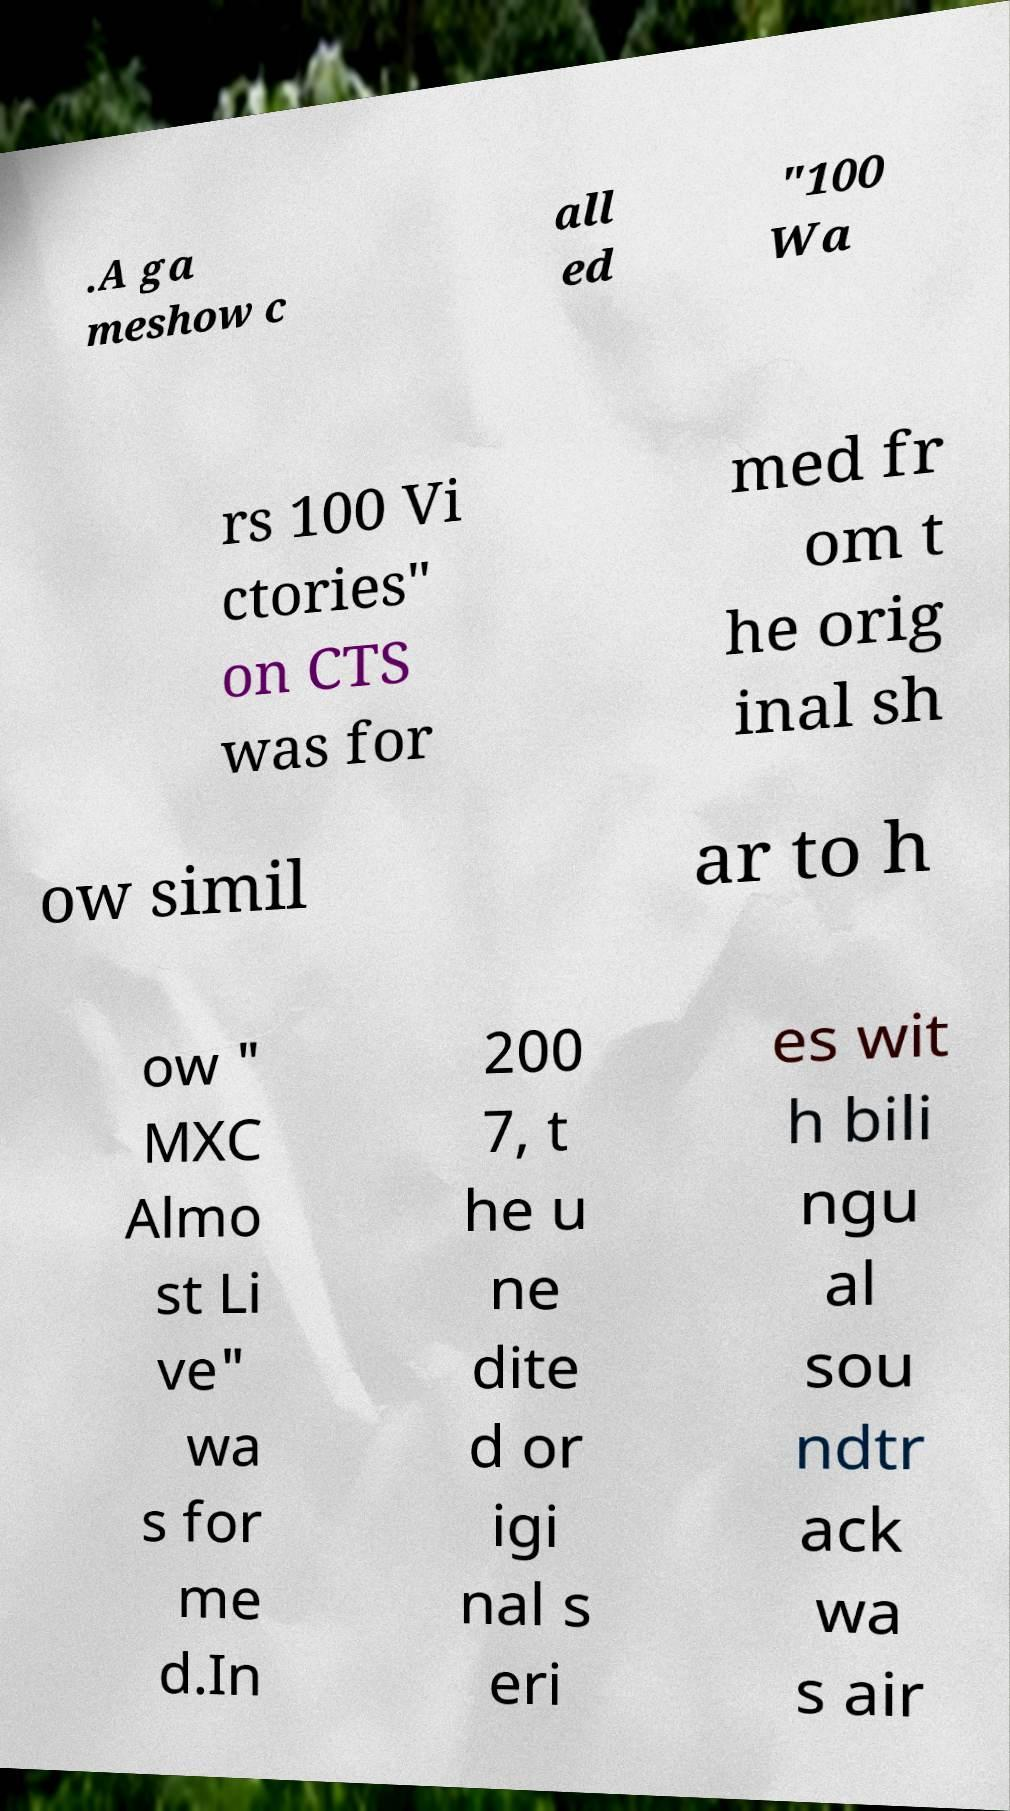Can you accurately transcribe the text from the provided image for me? .A ga meshow c all ed "100 Wa rs 100 Vi ctories" on CTS was for med fr om t he orig inal sh ow simil ar to h ow " MXC Almo st Li ve" wa s for me d.In 200 7, t he u ne dite d or igi nal s eri es wit h bili ngu al sou ndtr ack wa s air 